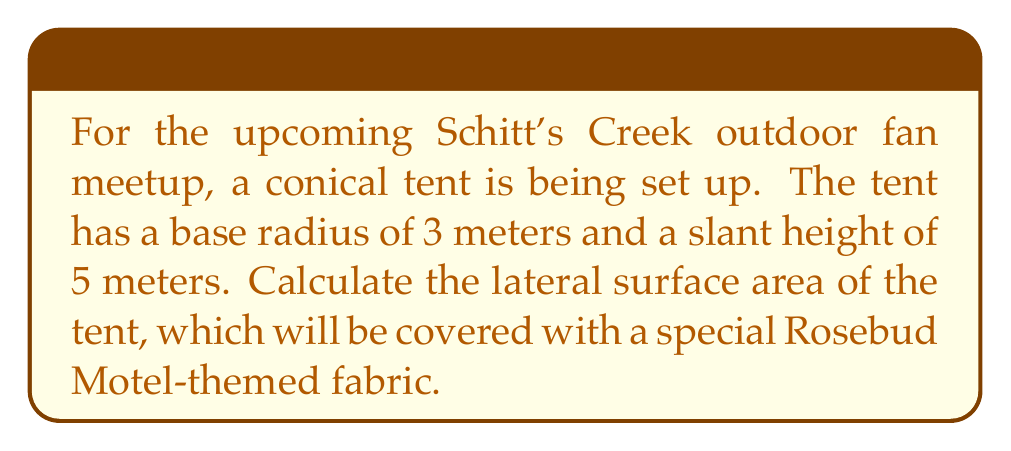Can you solve this math problem? Let's approach this step-by-step:

1) The lateral surface area of a cone is given by the formula:

   $$A = \pi r s$$

   Where:
   $A$ = lateral surface area
   $r$ = radius of the base
   $s$ = slant height of the cone

2) We are given:
   $r = 3$ meters
   $s = 5$ meters

3) Let's substitute these values into our formula:

   $$A = \pi \cdot 3 \cdot 5$$

4) Simplify:
   $$A = 15\pi$$

5) If we want to express this in square meters, we can calculate the approximate value:

   $$A \approx 15 \cdot 3.14159 \approx 47.12385$$

[asy]
import geometry;

size(200);
pair O=(0,0), A=(3,0), B=(0,4);
draw(O--A--B--cycle);
draw(Arc(O,A,90));
label("3m",O--A,S);
label("5m",A--B,NE);
label("r",O--A/2,N);
label("s",A--B/2,SE);
[/asy]

The diagram above illustrates the cross-section of the conical tent, showing the base radius (r) and slant height (s).
Answer: The lateral surface area of the conical tent is $15\pi$ square meters, or approximately 47.12 square meters. 